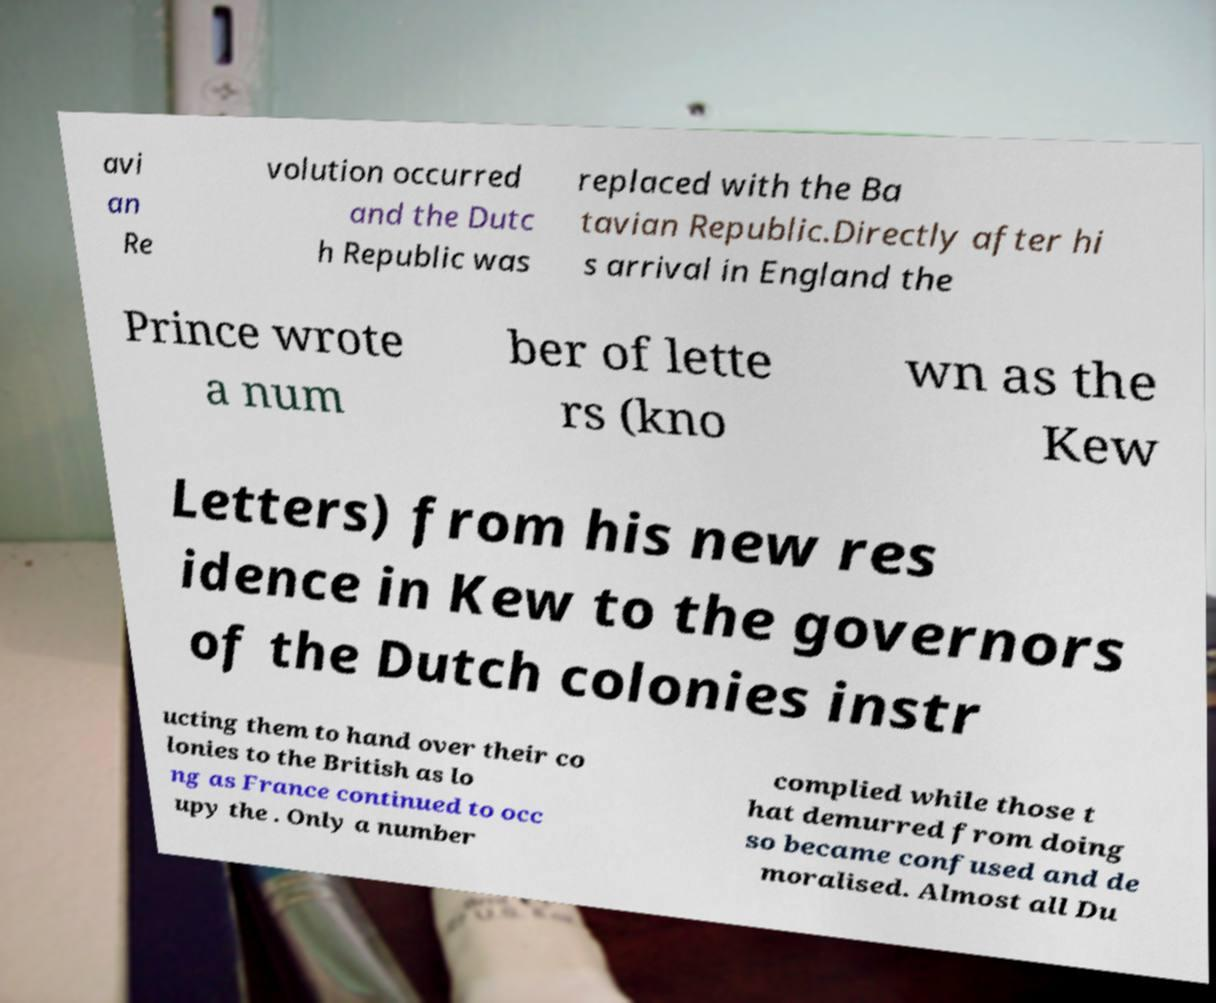For documentation purposes, I need the text within this image transcribed. Could you provide that? avi an Re volution occurred and the Dutc h Republic was replaced with the Ba tavian Republic.Directly after hi s arrival in England the Prince wrote a num ber of lette rs (kno wn as the Kew Letters) from his new res idence in Kew to the governors of the Dutch colonies instr ucting them to hand over their co lonies to the British as lo ng as France continued to occ upy the . Only a number complied while those t hat demurred from doing so became confused and de moralised. Almost all Du 